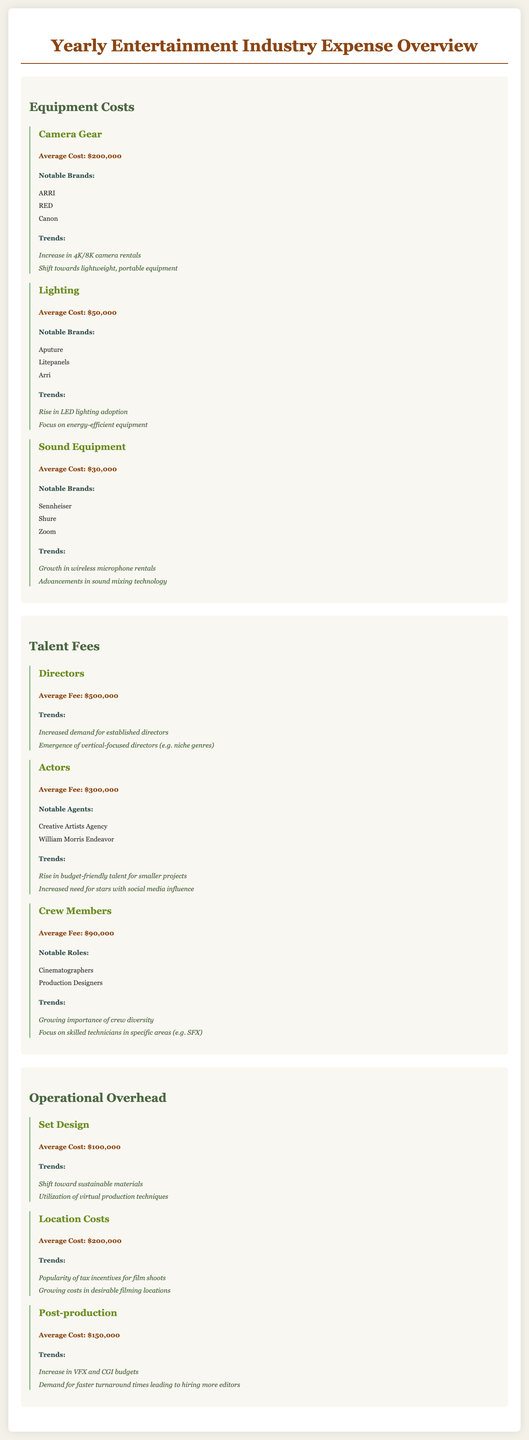What is the average cost of camera gear? The document states that the average cost of camera gear is $200,000.
Answer: $200,000 Which brand is notable for lighting equipment? The document lists Aputure, Litepanels, and Arri as notable brands for lighting equipment.
Answer: Aputure What is the average fee for directors? The average fee for directors is mentioned as $500,000 in the document.
Answer: $500,000 What trend is associated with sound equipment? The document indicates that there is a growth in wireless microphone rentals as a trend in sound equipment.
Answer: Growth in wireless microphone rentals What is the average cost of post-production? According to the document, the average cost of post-production is $150,000.
Answer: $150,000 Which expense area has a focus on sustainable materials? The document specifies that set design has a trend of shifting toward sustainable materials.
Answer: Set Design What notable agents are mentioned for actors? The document lists Creative Artists Agency and William Morris Endeavor as notable agents for actors.
Answer: Creative Artists Agency What is the average fee for crew members? The document states that the average fee for crew members is $90,000.
Answer: $90,000 What trend relates to location costs? The document highlights the popularity of tax incentives for film shoots as a trend related to location costs.
Answer: Popularity of tax incentives for film shoots 